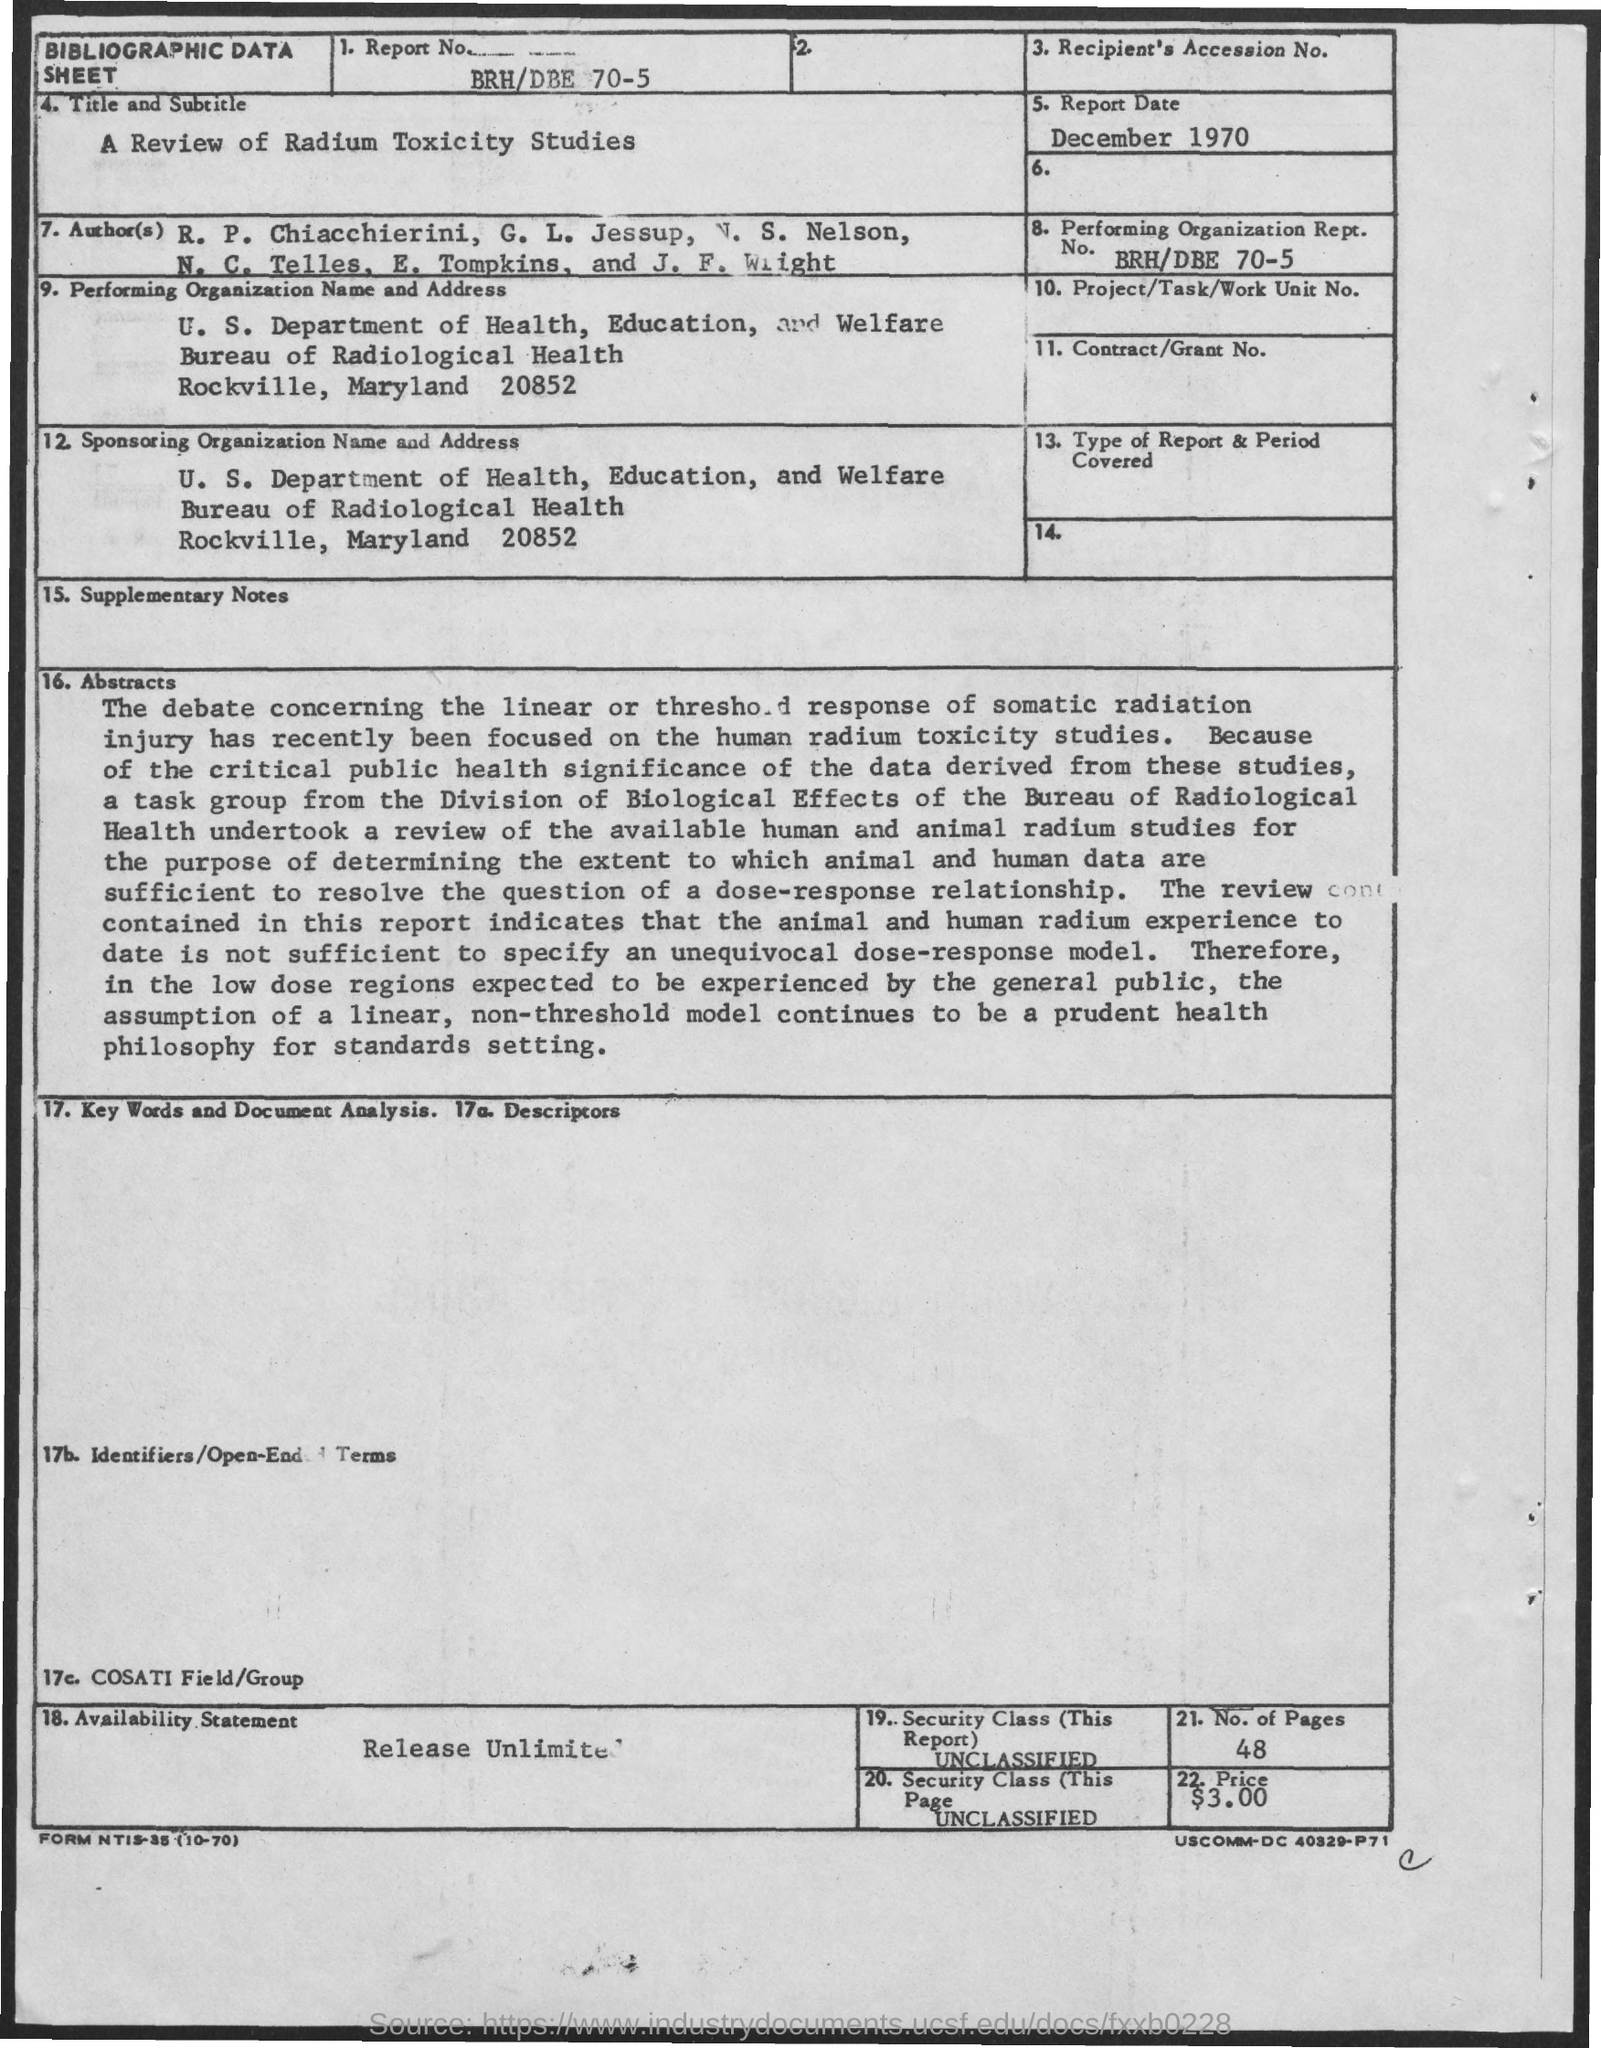Specify some key components in this picture. The report date is December 1970. The Report Number is BRH/DBE 70-5. 